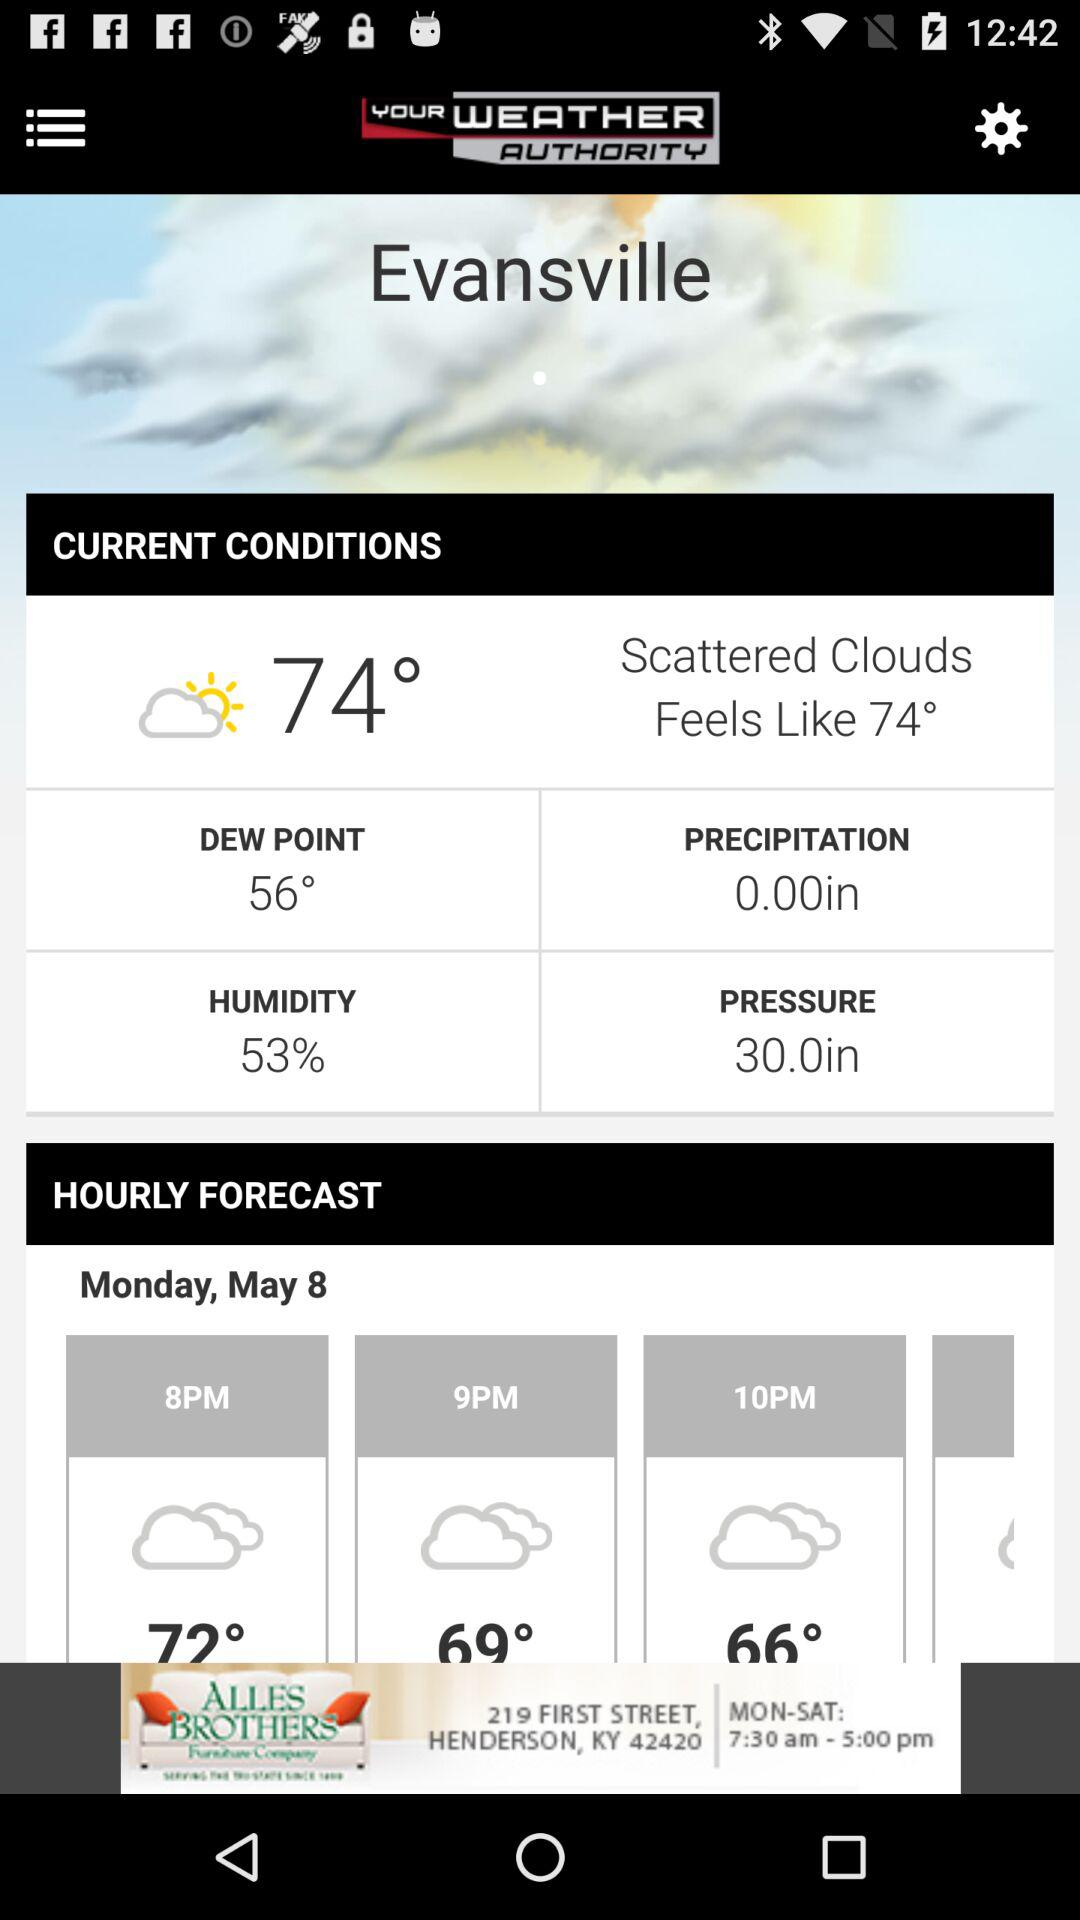Will it continue to be cloudy after 10 PM?
When the provided information is insufficient, respond with <no answer>. <no answer> 